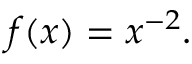<formula> <loc_0><loc_0><loc_500><loc_500>f ( x ) = x ^ { - 2 } .</formula> 